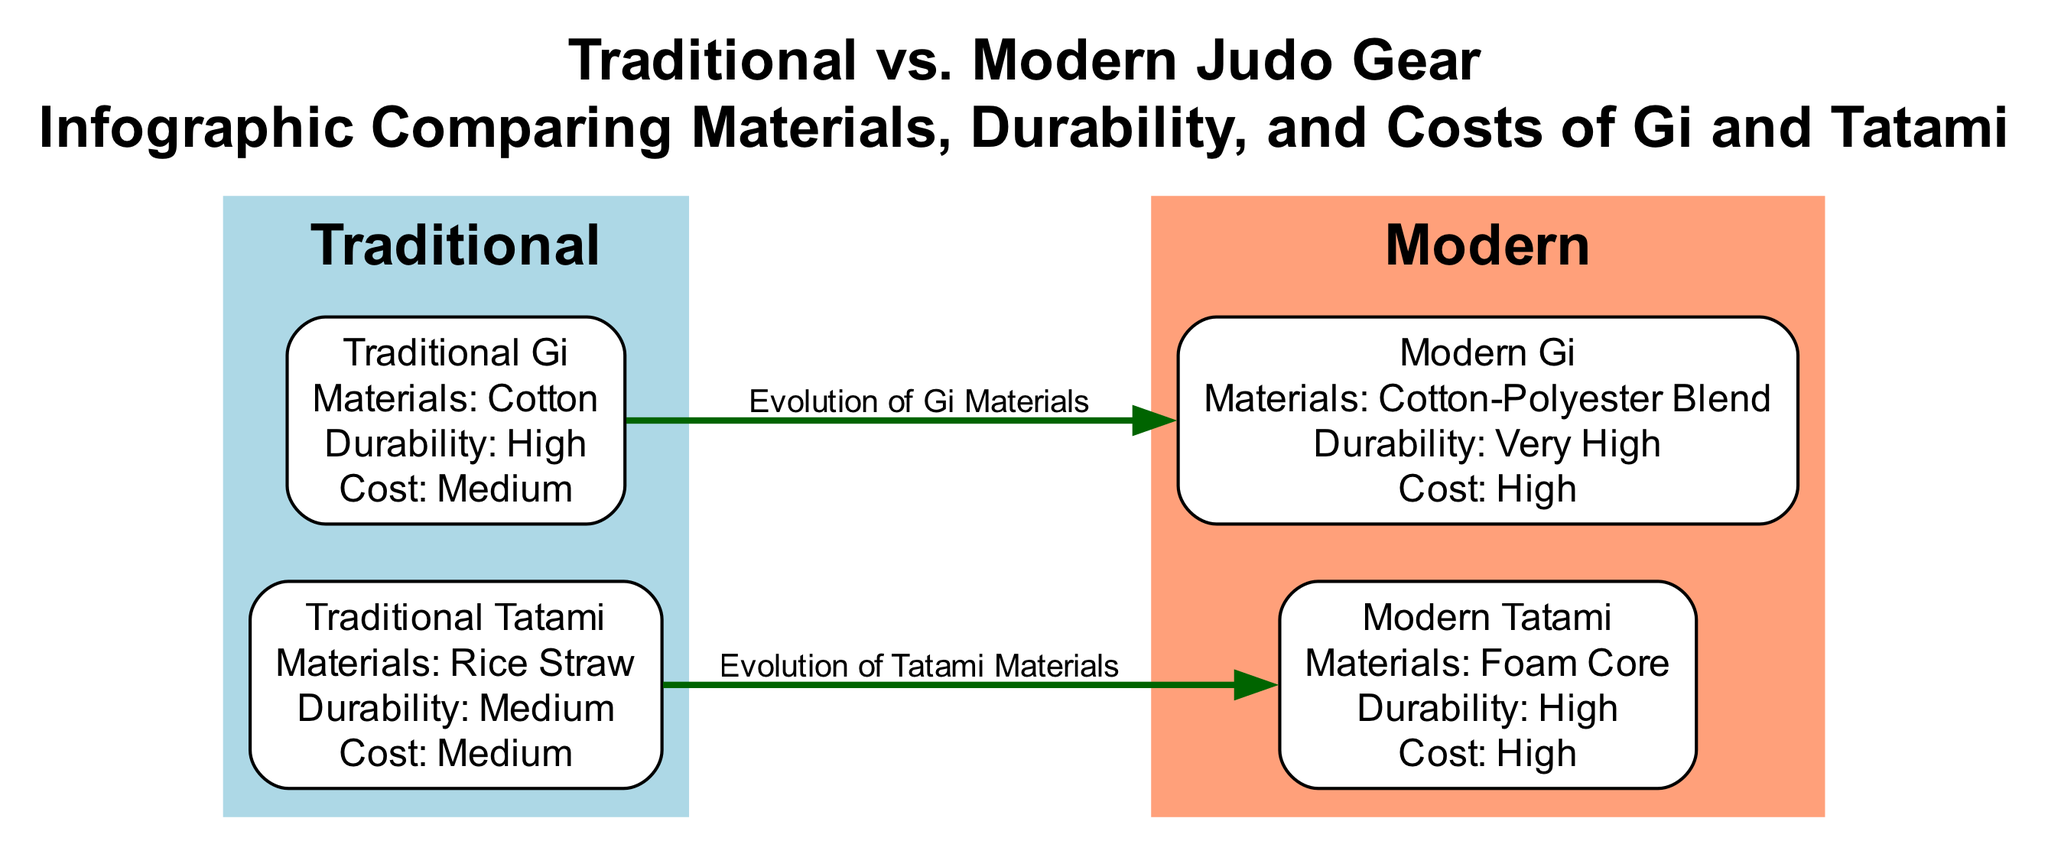What's the material used in the Traditional Gi? The diagram shows that the Traditional Gi is made of cotton, which is stated in the description of the node for Traditional Gi.
Answer: Cotton What is the durability level of Modern Tatami? The node for Modern Tatami indicates that its durability is rated as high, which is explicitly mentioned in the additional information of that node.
Answer: High How many nodes are there in the diagram? By counting the entries in the "nodes" section of the data, there are a total of four nodes: Traditional Gi, Modern Gi, Traditional Tatami, and Modern Tatami.
Answer: 4 What defines the evolution from Traditional Gi to Modern Gi? The edge connecting Traditional Gi to Modern Gi describes the evolution of Gi materials, indicating a transition from traditional to modern materials.
Answer: Evolution of Gi Materials What is the cost classification for Modern Gi? According to the information given in the Modern Gi node, the cost is classified as high, which is clearly mentioned in the cost section of that node.
Answer: High Which traditional gear has medium durability? The diagram indicates that the Traditional Tatami has medium durability, as stated in its additional information section.
Answer: Traditional Tatami What materials are used in Modern Tatami? The description of the Modern Tatami node specifies that it is made of a foam core, which directly answers the question regarding the materials used.
Answer: Foam Core What is the relationship between Traditional Tatami and Modern Tatami? The edge connecting Traditional Tatami to Modern Tatami describes the evolution of tatami materials, which shows the relationship between the two types of tatami.
Answer: Evolution of Tatami Materials Which is more durable, Traditional Gi or Modern Gi? Comparing the durability levels provided in the nodes, Modern Gi is rated as very high durability, while Traditional Gi is rated as high, making Modern Gi more durable.
Answer: Modern Gi 